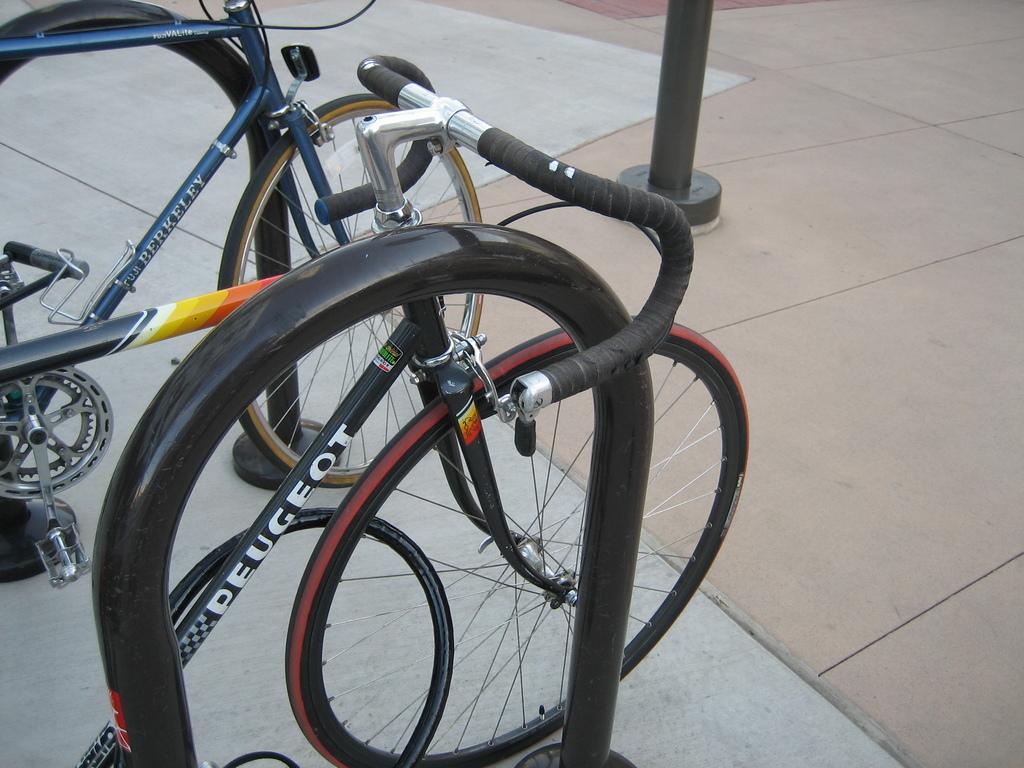How would you summarize this image in a sentence or two? In this image I can see the bicycles. To the side of the bicycles I can see the black color rod. In the background I can see the black color pole. 